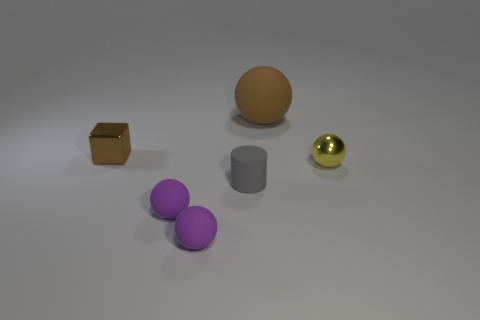Is there anything else that has the same size as the gray rubber cylinder?
Your response must be concise. Yes. There is a cylinder that is the same size as the cube; what material is it?
Your answer should be very brief. Rubber. How big is the ball behind the shiny object in front of the metal object behind the yellow shiny object?
Offer a terse response. Large. The brown sphere that is the same material as the small gray object is what size?
Give a very brief answer. Large. There is a shiny ball; is it the same size as the matte object that is behind the tiny yellow metal ball?
Offer a terse response. No. There is a small metal thing that is on the right side of the tiny rubber cylinder; what shape is it?
Provide a short and direct response. Sphere. Is there a small purple matte object that is in front of the small metal thing that is behind the small shiny thing right of the small gray rubber object?
Keep it short and to the point. Yes. There is a tiny yellow thing that is the same shape as the large brown matte thing; what is its material?
Your answer should be very brief. Metal. What number of cubes are either brown metallic things or purple objects?
Make the answer very short. 1. There is a metal thing to the right of the gray matte thing; does it have the same size as the brown thing that is to the left of the cylinder?
Give a very brief answer. Yes. 